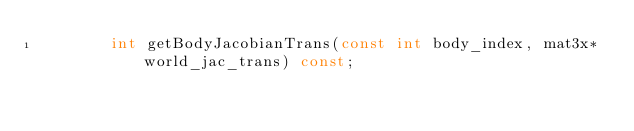<code> <loc_0><loc_0><loc_500><loc_500><_C++_>        int getBodyJacobianTrans(const int body_index, mat3x* world_jac_trans) const;</code> 